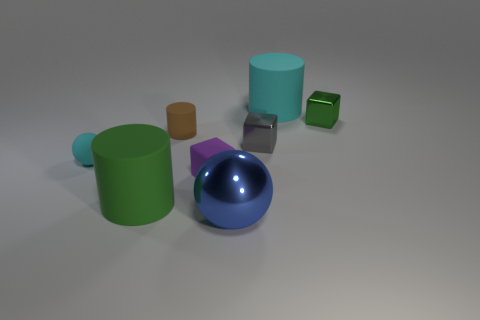How many other things are there of the same material as the large blue sphere?
Your response must be concise. 2. Do the big object that is on the left side of the small purple rubber block and the sphere that is behind the blue metallic ball have the same material?
Your answer should be compact. Yes. How many cylinders are both behind the green shiny block and to the left of the small gray cube?
Your answer should be compact. 0. Are there any cyan matte things that have the same shape as the small brown rubber thing?
Your response must be concise. Yes. What shape is the metal thing that is the same size as the green matte thing?
Make the answer very short. Sphere. Are there an equal number of small brown things that are in front of the tiny cyan rubber thing and tiny purple cubes in front of the green matte object?
Offer a very short reply. Yes. How big is the matte thing on the right side of the tiny matte object that is in front of the rubber ball?
Make the answer very short. Large. Is there a gray metal block that has the same size as the green metal cube?
Provide a short and direct response. Yes. There is a tiny cylinder that is the same material as the big cyan thing; what is its color?
Provide a succinct answer. Brown. Is the number of purple matte things less than the number of big cyan metal balls?
Keep it short and to the point. No. 